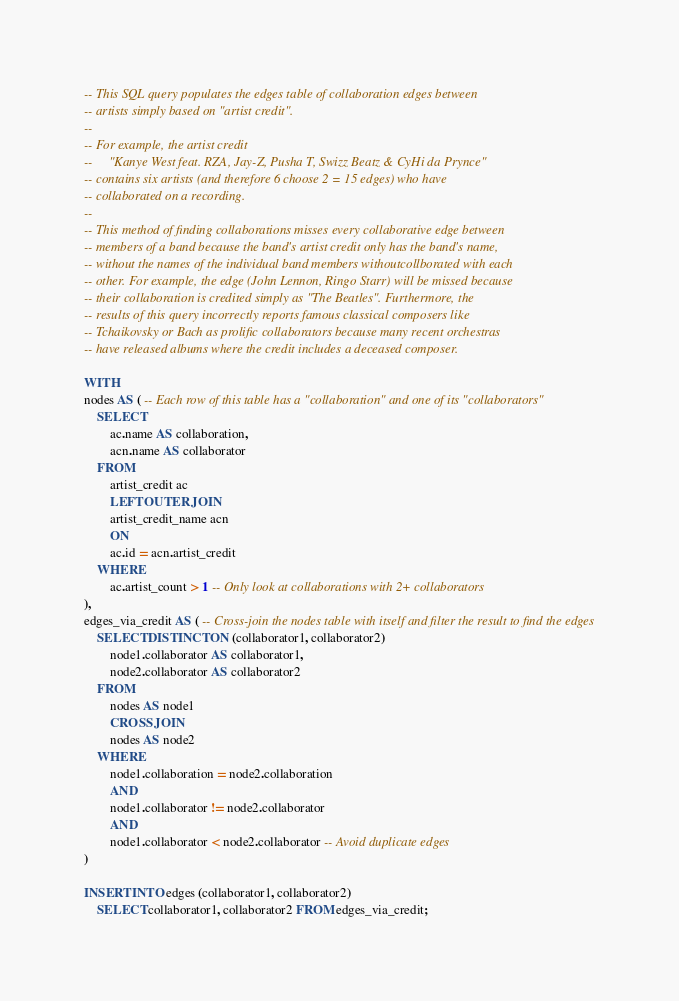<code> <loc_0><loc_0><loc_500><loc_500><_SQL_>-- This SQL query populates the edges table of collaboration edges between
-- artists simply based on "artist credit".
--
-- For example, the artist credit
--     "Kanye West feat. RZA, Jay-Z, Pusha T, Swizz Beatz & CyHi da Prynce"
-- contains six artists (and therefore 6 choose 2 = 15 edges) who have
-- collaborated on a recording.
--
-- This method of finding collaborations misses every collaborative edge between
-- members of a band because the band's artist credit only has the band's name,
-- without the names of the individual band members withoutcollborated with each
-- other. For example, the edge (John Lennon, Ringo Starr) will be missed because
-- their collaboration is credited simply as "The Beatles". Furthermore, the
-- results of this query incorrectly reports famous classical composers like
-- Tchaikovsky or Bach as prolific collaborators because many recent orchestras
-- have released albums where the credit includes a deceased composer.

WITH
nodes AS ( -- Each row of this table has a "collaboration" and one of its "collaborators"
    SELECT
        ac.name AS collaboration,
        acn.name AS collaborator
    FROM
        artist_credit ac
        LEFT OUTER JOIN
        artist_credit_name acn
        ON
        ac.id = acn.artist_credit
    WHERE
        ac.artist_count > 1 -- Only look at collaborations with 2+ collaborators
),
edges_via_credit AS ( -- Cross-join the nodes table with itself and filter the result to find the edges
    SELECT DISTINCT ON (collaborator1, collaborator2)
        node1.collaborator AS collaborator1,
        node2.collaborator AS collaborator2
    FROM
        nodes AS node1
        CROSS JOIN
        nodes AS node2
    WHERE
        node1.collaboration = node2.collaboration
        AND
        node1.collaborator != node2.collaborator
        AND
        node1.collaborator < node2.collaborator -- Avoid duplicate edges
)

INSERT INTO edges (collaborator1, collaborator2)
    SELECT collaborator1, collaborator2 FROM edges_via_credit;
</code> 